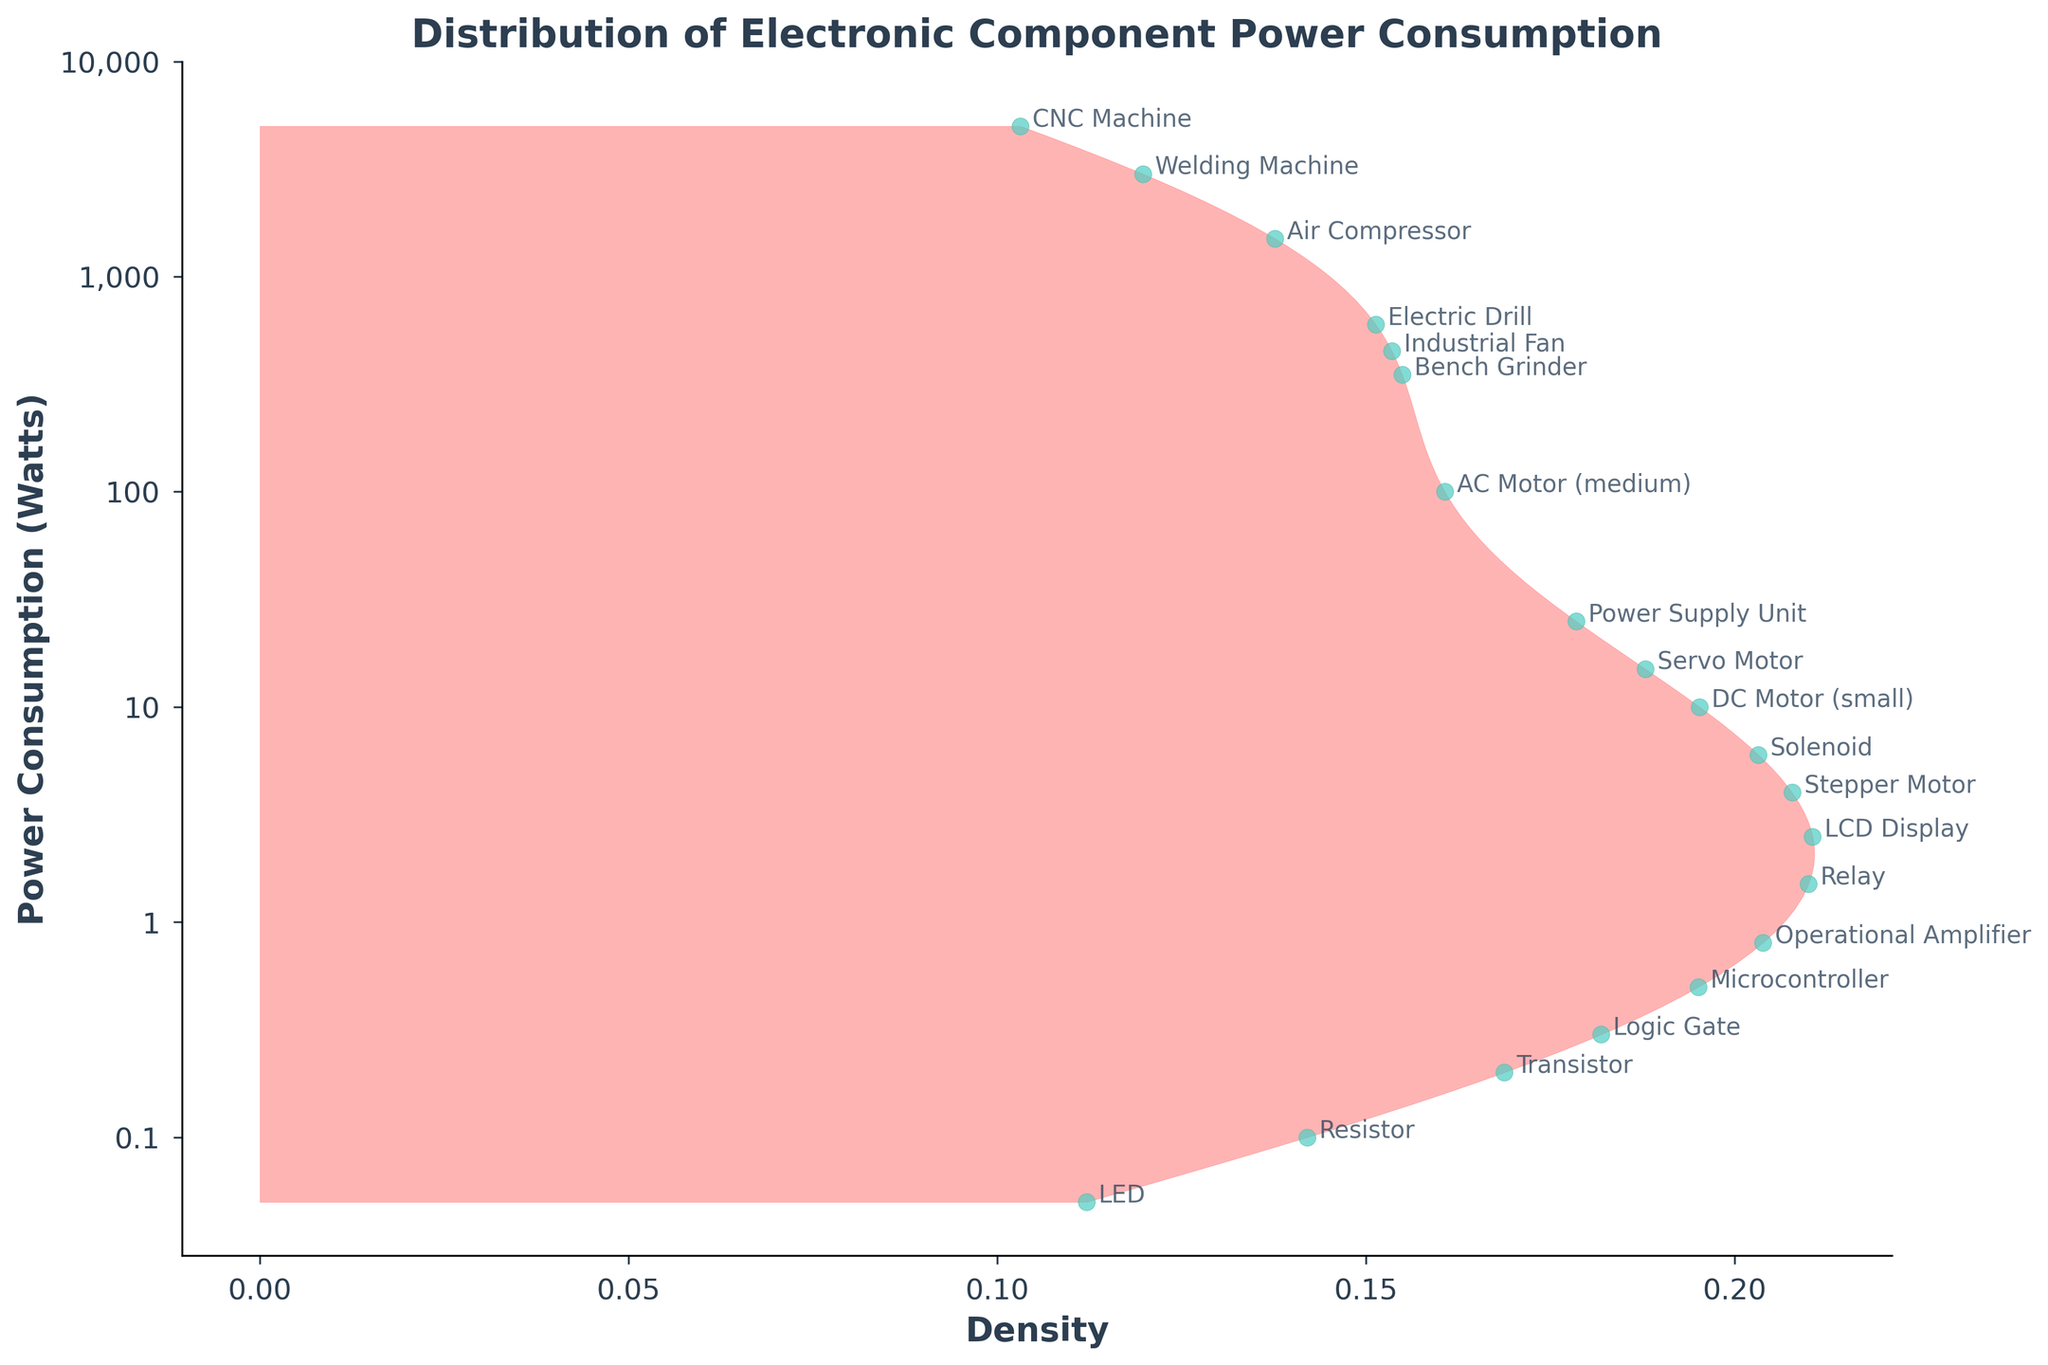What's the maximum power consumption value displayed in the plot? The largest log-transformed power consumption value corresponds to approximately \(10^4\) Watts, which is the power consumption range of the CNC Machine.
Answer: 5,000 Watts How many types of electronic components have power consumptions above 100 Watts? From the y-axis labels, components plotted above log10(100) include the Electric Drill, Bench Grinder, Industrial Fan, Air Compressor, Welding Machine, and CNC Machine.
Answer: 6 components Which component has the lowest power consumption? The lowest log-transformed value coincides with the component labeled as LED in the annotation.
Answer: LED What is the range of power consumption displayed in the plot? The range can be inferred from the lowest and highest values on the y-axis, which spans from 0.1 Watt (10^(-1)) to 5,000 Watts (10^4).
Answer: 0.1 Watt to 5,000 Watts How does the density of components vary with power consumption? The density varies with more components clustered around the lower power consumption range (under 10 Watts), as indicated by higher density areas in the range below 10.
Answer: Higher at lower power consumptions, lower at higher power consumptions Which two components have the most similar power consumption values according to their positions in the plot? The Operational Amplifier and Logic Gate are closest to each other in their transformed power consumption values, indicated by their proximity on the y-axis.
Answer: Operational Amplifier and Logic Gate What is the power consumption of the component that is marked near log10(1.5)? The component labeled Relay is plotted near log10(1.5) which corresponds to approximately 1.5 Watts.
Answer: Relay Describe the general trend observed in the power consumption of components. Most components have lower power consumption, as indicated by the higher density and more clustered points towards the lower end of the power spectrum. There are fewer components with high power consumption.
Answer: Higher density at lower power Which component consumes more power: the Servo Motor or the Stepper Motor? The Servo Motor is plotted above the Stepper Motor in the log-transformed scale, indicating higher power consumption.
Answer: Servo Motor Is there more variability in power consumption among low-power or high-power components? The low-power range (0.1-10 Watts) shows more variability with multiple components closely packed and differentiated, while the high-power components (above 100 Watts) are fewer and farther apart.
Answer: Low-power components 